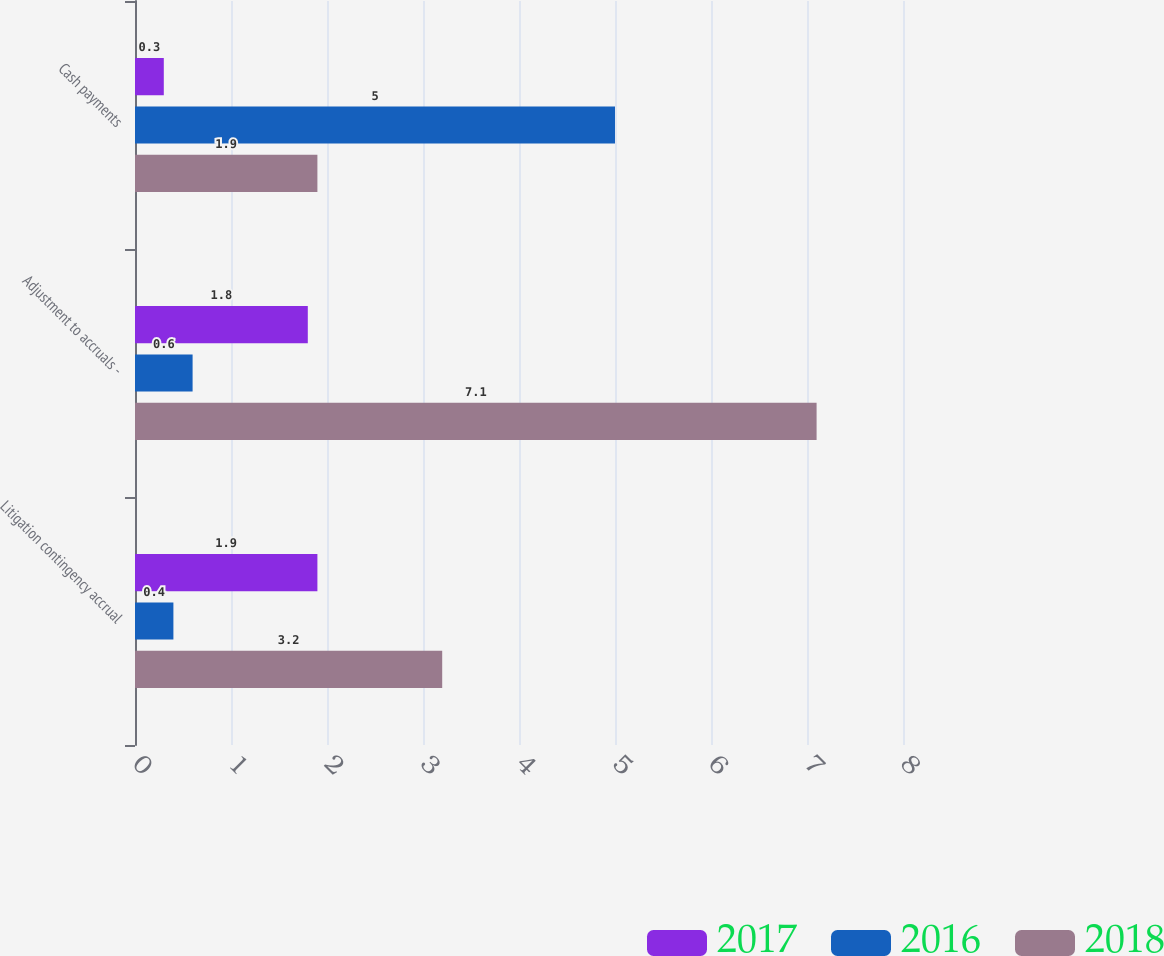Convert chart. <chart><loc_0><loc_0><loc_500><loc_500><stacked_bar_chart><ecel><fcel>Litigation contingency accrual<fcel>Adjustment to accruals -<fcel>Cash payments<nl><fcel>2017<fcel>1.9<fcel>1.8<fcel>0.3<nl><fcel>2016<fcel>0.4<fcel>0.6<fcel>5<nl><fcel>2018<fcel>3.2<fcel>7.1<fcel>1.9<nl></chart> 